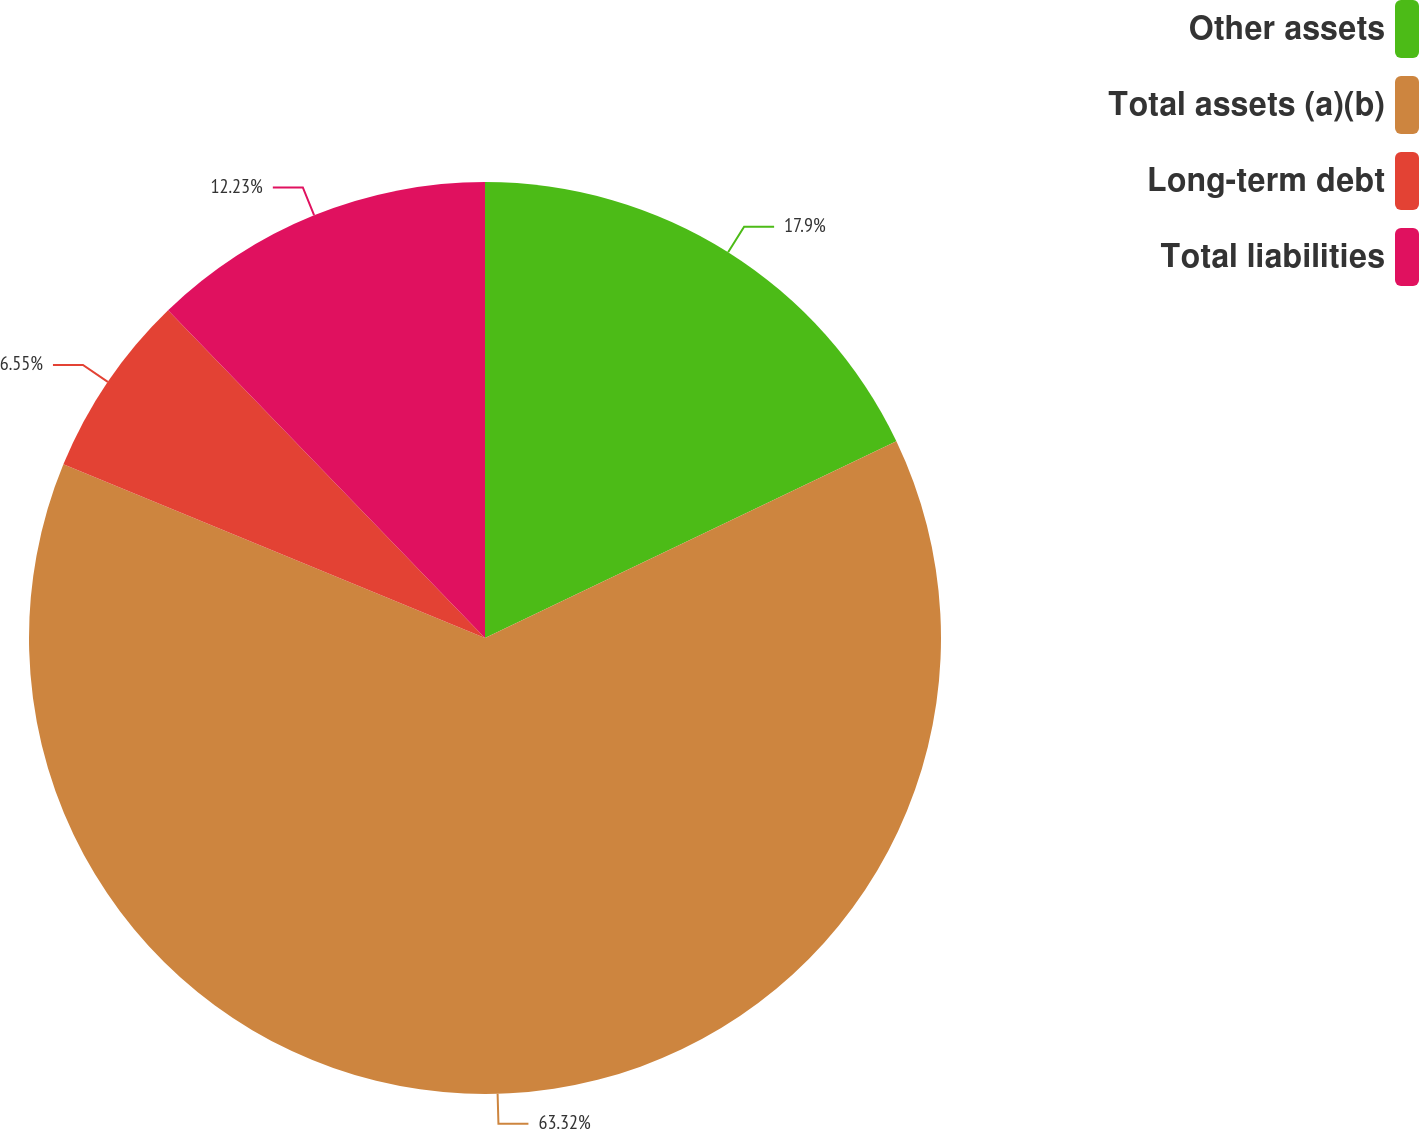Convert chart. <chart><loc_0><loc_0><loc_500><loc_500><pie_chart><fcel>Other assets<fcel>Total assets (a)(b)<fcel>Long-term debt<fcel>Total liabilities<nl><fcel>17.9%<fcel>63.32%<fcel>6.55%<fcel>12.23%<nl></chart> 